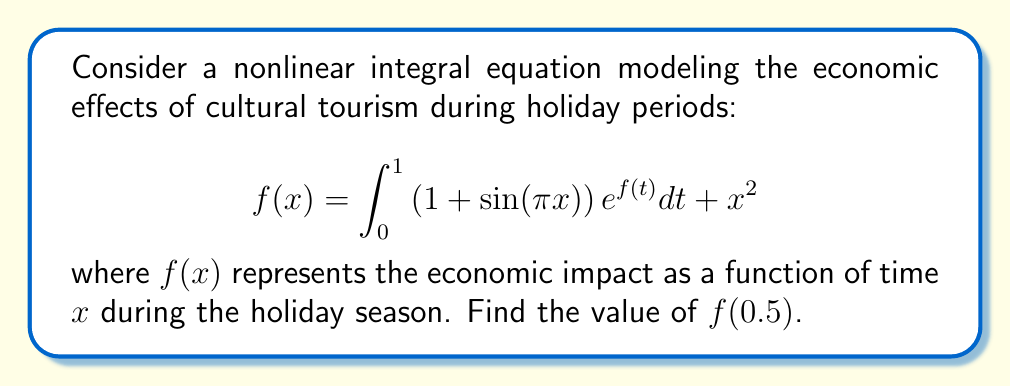Give your solution to this math problem. To solve this nonlinear integral equation, we'll use an iterative method:

1) First, let's make an initial guess for $f(x)$. A simple guess would be $f_0(x) = x^2$.

2) Now, we'll use this initial guess to create a better approximation:

   $$f_1(x) = \int_0^1 \left(1 + \sin(\pi x)\right) e^{x^2} dt + x^2$$

3) Evaluate the integral:

   $$f_1(x) = \left(1 + \sin(\pi x)\right) \int_0^1 e^{t^2} dt + x^2$$

   The integral $\int_0^1 e^{t^2} dt$ is a constant. Let's call it $C$. It can be approximated numerically to be about 1.4628.

4) So our first approximation is:

   $$f_1(x) = 1.4628(1 + \sin(\pi x)) + x^2$$

5) We can continue this process to get better approximations, but for this problem, we'll stop here.

6) To find $f(0.5)$, we substitute $x = 0.5$ into our approximation:

   $$f_1(0.5) = 1.4628(1 + \sin(\pi \cdot 0.5)) + 0.5^2$$

7) Simplify:

   $$f_1(0.5) = 1.4628(1 + 1) + 0.25 = 3.1756$$

Therefore, our approximation for $f(0.5)$ is 3.1756.
Answer: $f(0.5) \approx 3.1756$ 